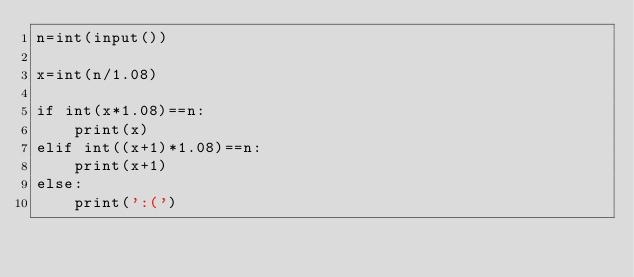Convert code to text. <code><loc_0><loc_0><loc_500><loc_500><_Python_>n=int(input())

x=int(n/1.08)

if int(x*1.08)==n:
    print(x)
elif int((x+1)*1.08)==n:
    print(x+1)
else:
    print(':(')</code> 